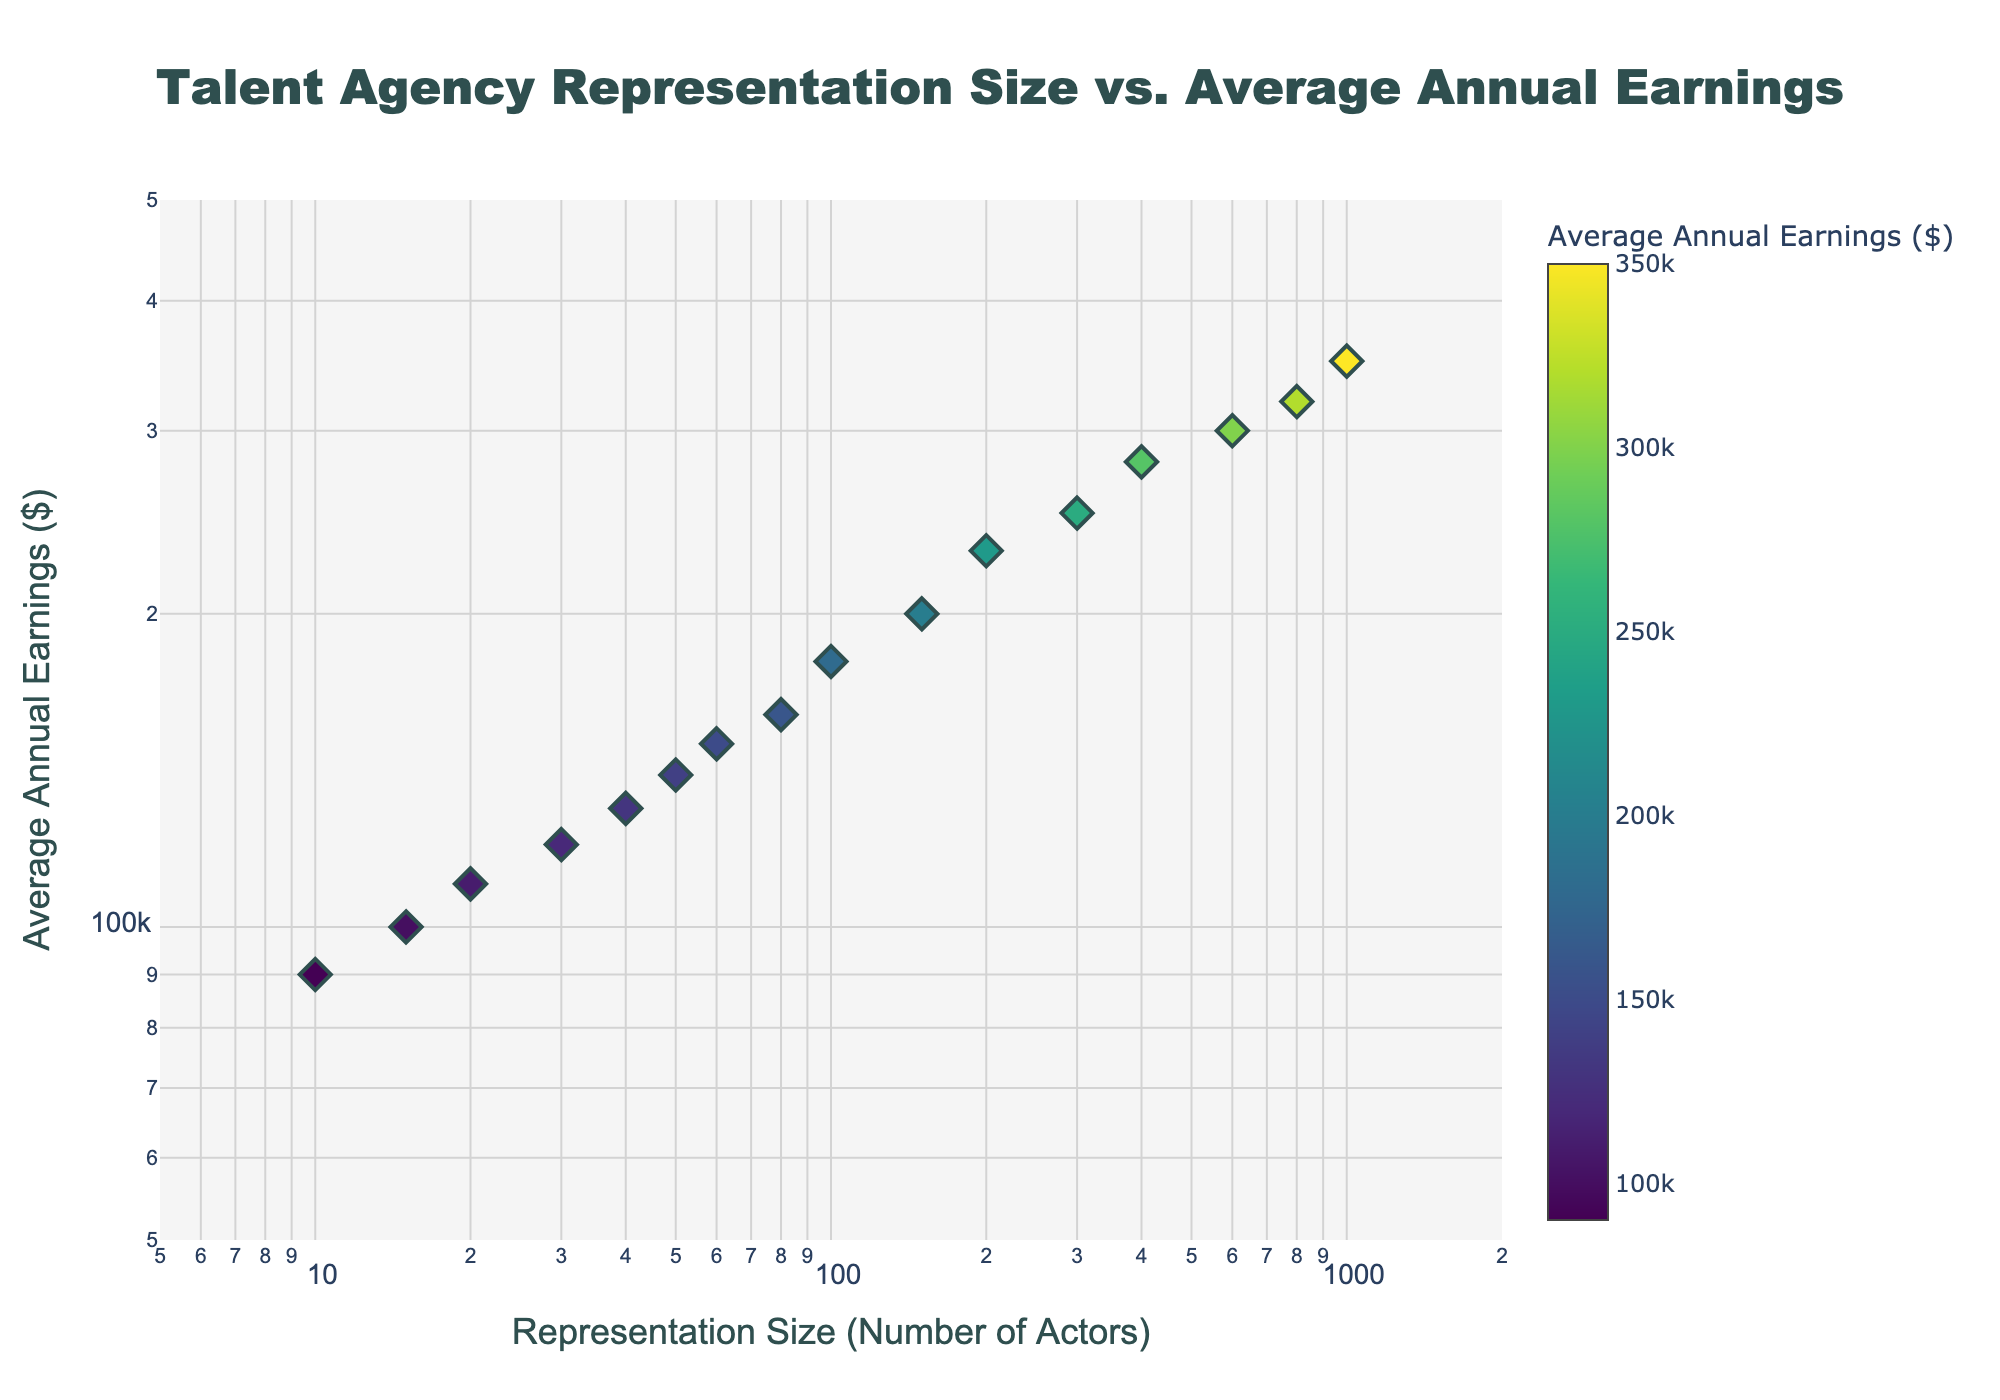What is the title of the figure? The title is usually found at the top of the figure. Here, it is written at the top center in large, bold font.
Answer: Talent Agency Representation Size vs. Average Annual Earnings How many agencies have their points annotated on the plot? The plot includes annotations for top agencies based on their representation size. We can see that there are three annotated points on the plot.
Answer: Three What is the average annual earnings of the agency with the smallest representation size? Look for the agency with the smallest x-value (Representation Size). The smallest size is 10, which corresponds to the Smith & Hervey/Grimes Talent Agency. The y-value is the Average Annual Earnings.
Answer: $90,000 Which agency has the highest average annual earnings, and what is that amount? Find the point with the highest y-value (Average Annual Earnings). The highest value reaches $350,000 and corresponds to Creative Artists Agency.
Answer: Creative Artists Agency, $350,000 What is the representation size range displayed on the x-axis? The x-axis displays the Representation Size on a log scale, ranging from just under 10 to 2,000 actors. These numbers correspond to the axis labels and tick marks on the x-axis, converted from log scale to numeric scale.
Answer: ~10 to 2,000 What is the relationship between representation size and average annual earnings? Observing the scatter plot, the general trend shows that agencies with larger representation sizes tend to have higher average annual earnings. This is determined by the upward spread of the points as representation size increases.
Answer: Positive correlation How does the average annual earnings of ICM Partners compare to that of Paradigm Talent Agency? Locate ICM Partners and Paradigm Talent Agency. ICM Partners has an average annual earnings of $280,000, while Paradigm Talent Agency has $250,000. By comparing these values:
Answer: ICM Partners > Paradigm Talent Agency What's the difference in representation size between William Morris Endeavor and United Talent Agency? Look at the x-values for both agencies. William Morris Endeavor has 800, while United Talent Agency has 600. The difference is calculated by subtracting the smaller value from the larger one.
Answer: 200 Between APA Agency and Abrams Artists Agency, which one represents fewer actors and what are their respective average annual earnings? Locate APA Agency (150 actors, $200,000) and Abrams Artists Agency (30 actors, $120,000) on the plot. APA Agency represents more actors, thus Abrams Artists Agency represents fewer actors.
Answer: Abrams Artists Agency, $120,000 